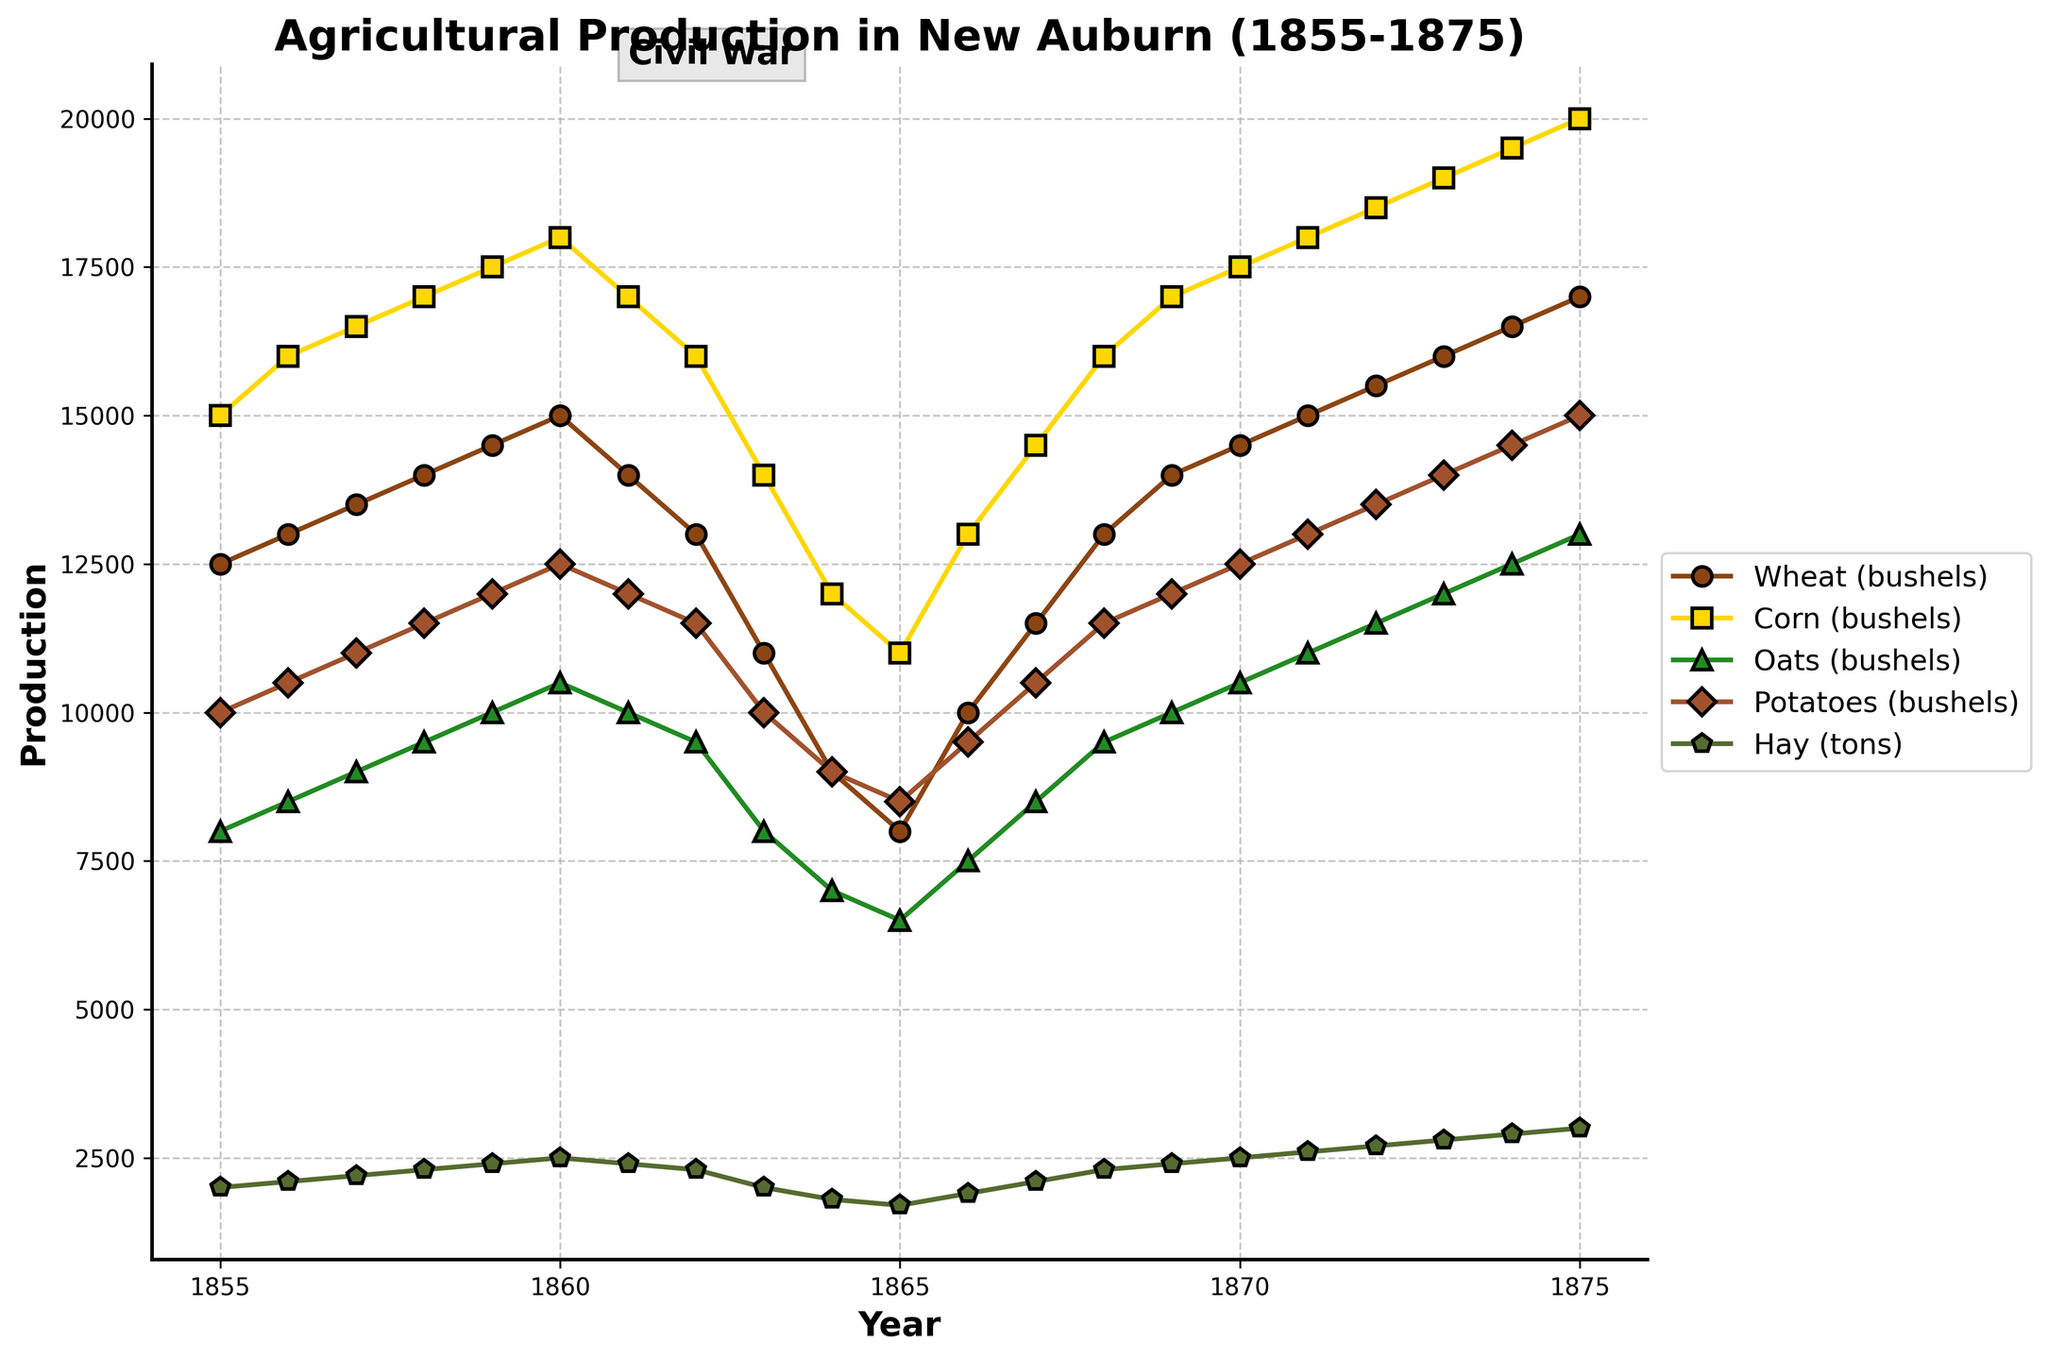What was the production of wheat in 1860? Locate the year 1860 on the x-axis and follow it up to the wheat (bushels) line, which is the brown line. The y-axis indicates the production level.
Answer: 15000 bushels How did corn production change from 1860 to 1865? Find 1860 and 1865 on the x-axis and look at the height of the yellow corn (bushels) line at these points. In 1860, it’s at 18000 bushels, and in 1865, it’s at 11000 bushels. Subtract the latter from the former to find the change.
Answer: Decreased by 7000 bushels Did any crop show an increasing trend throughout the entire period from 1855 to 1875? Look at each crop line from 1855 to 1875. All crops had fluctuations, especially during the war period, but the hay (tons) line, which is the green line, shows a general increasing trend towards the end.
Answer: Yes, hay In which year did oats production drop the most? Examine the purple oats (bushels) line for the steepest decline. The largest drop occurs between 1861 and 1862.
Answer: 1862 Compare the potato production in 1858 and 1874. Which year had higher production? Follow the blue potatoes (bushels) line up from 1858 and 1874 on the x-axis to see the production levels. Production in 1858 is 11500 bushels, and in 1874 it’s 14500 bushels.
Answer: 1874 What is the relationship between the Civil War period and the trend of wheat production? Notice the shaded area labeled "Civil War" from 1861 to 1865 and observe the brown wheat (bushels) line. Wheat production declines during this period.
Answer: Decrease What's the average hay production over the 5-year span from 1865 to 1870? First, find the hay (tons) production for each year from 1865 to 1870: 1700, 1900, 2100, 2300, 2500. Sum these values: 1700 + 1900 + 2100 + 2300 + 2500 = 10500. Divide by 5 to find the average.
Answer: 2100 tons Which crop had the least production in 1864? Locate 1864 on the x-axis and compare the height of each crop line. The orange potatoes (bushels) line is the lowest at 9000 bushels.
Answer: Potatoes How much did potato production increase from 1865 to 1875? Find 1865 and 1875 on the x-axis and look at the potato (bushels) line. In 1865, it’s at 8500 bushels, and in 1875, it’s at 15000 bushels. Subtract the former from the latter to find the increase.
Answer: 6500 bushels Is there a year post-Civil War when production levels returned to or exceeded pre-war levels? Compare crop production levels from the pre-war year 1860 with the immediate post-war years (1866 onwards). In 1869, the production levels approximate or exceed those in 1860.
Answer: 1869 